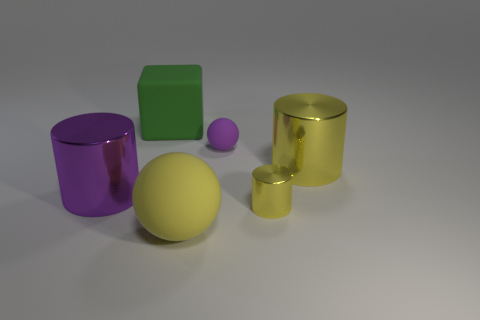How many other things are the same shape as the tiny yellow metal thing?
Keep it short and to the point. 2. There is a shiny object in front of the thing to the left of the big green block; what is its size?
Provide a short and direct response. Small. Are any cylinders visible?
Offer a terse response. Yes. There is a object on the left side of the green rubber block; what number of purple metallic cylinders are to the left of it?
Your answer should be very brief. 0. What shape is the small thing that is behind the large yellow metallic cylinder?
Provide a succinct answer. Sphere. The tiny object behind the yellow cylinder to the right of the small yellow shiny thing that is in front of the green object is made of what material?
Your response must be concise. Rubber. What number of other objects are the same size as the green matte thing?
Keep it short and to the point. 3. There is a big purple thing that is the same shape as the tiny yellow shiny thing; what material is it?
Your answer should be compact. Metal. What color is the large block?
Provide a short and direct response. Green. What is the color of the big matte object that is behind the shiny cylinder that is behind the large purple thing?
Your answer should be very brief. Green. 